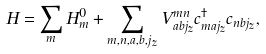<formula> <loc_0><loc_0><loc_500><loc_500>H = \sum _ { m } H _ { m } ^ { 0 } + \sum _ { m , n , a , b , j _ { z } } V _ { a b j _ { z } } ^ { m n } c _ { m a j _ { z } } ^ { \dag } c _ { n b j _ { z } } ,</formula> 